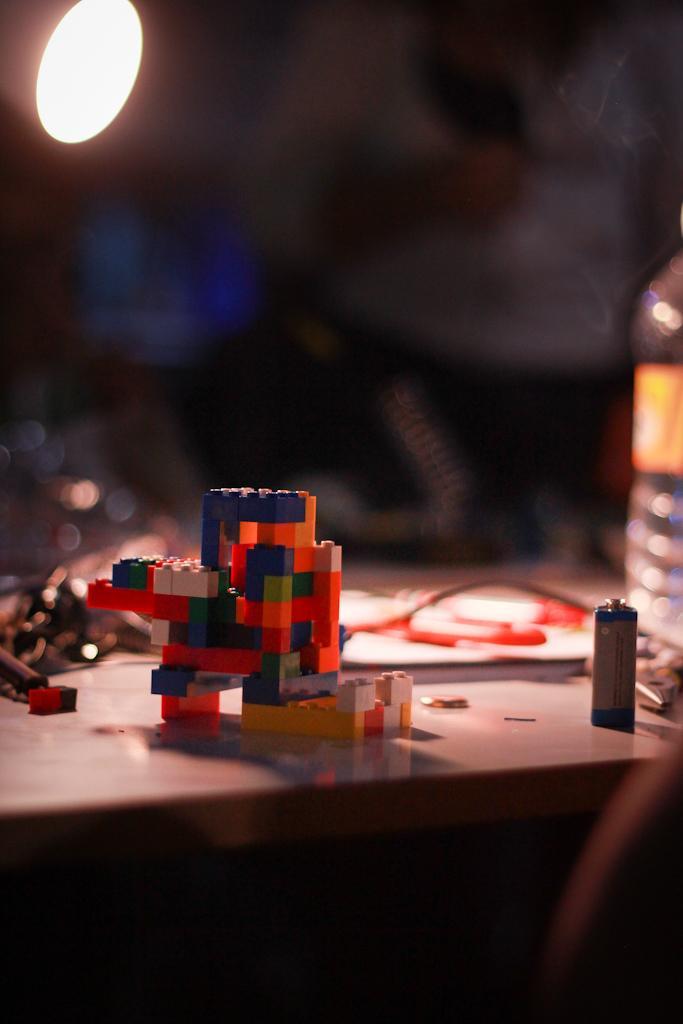In one or two sentences, can you explain what this image depicts? In this image there is a Lego toy, water and few other objects on the table. On the left side of the image there is a light and the background of the image is blur. 